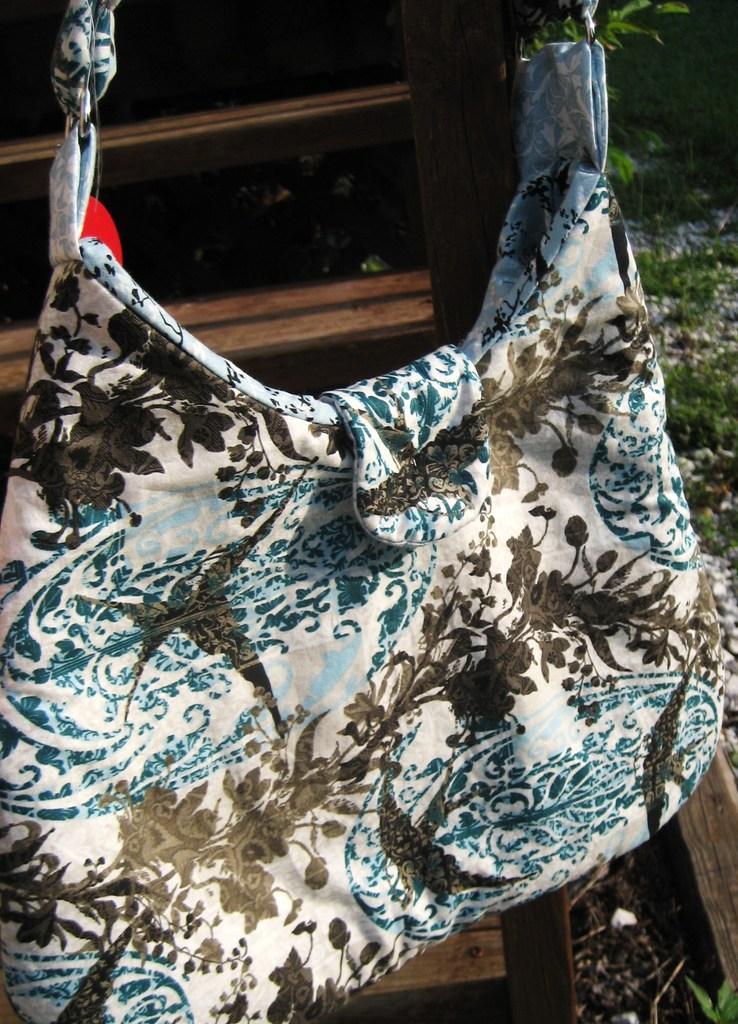Can you describe this image briefly? In this image I can see a handbag of white color. 